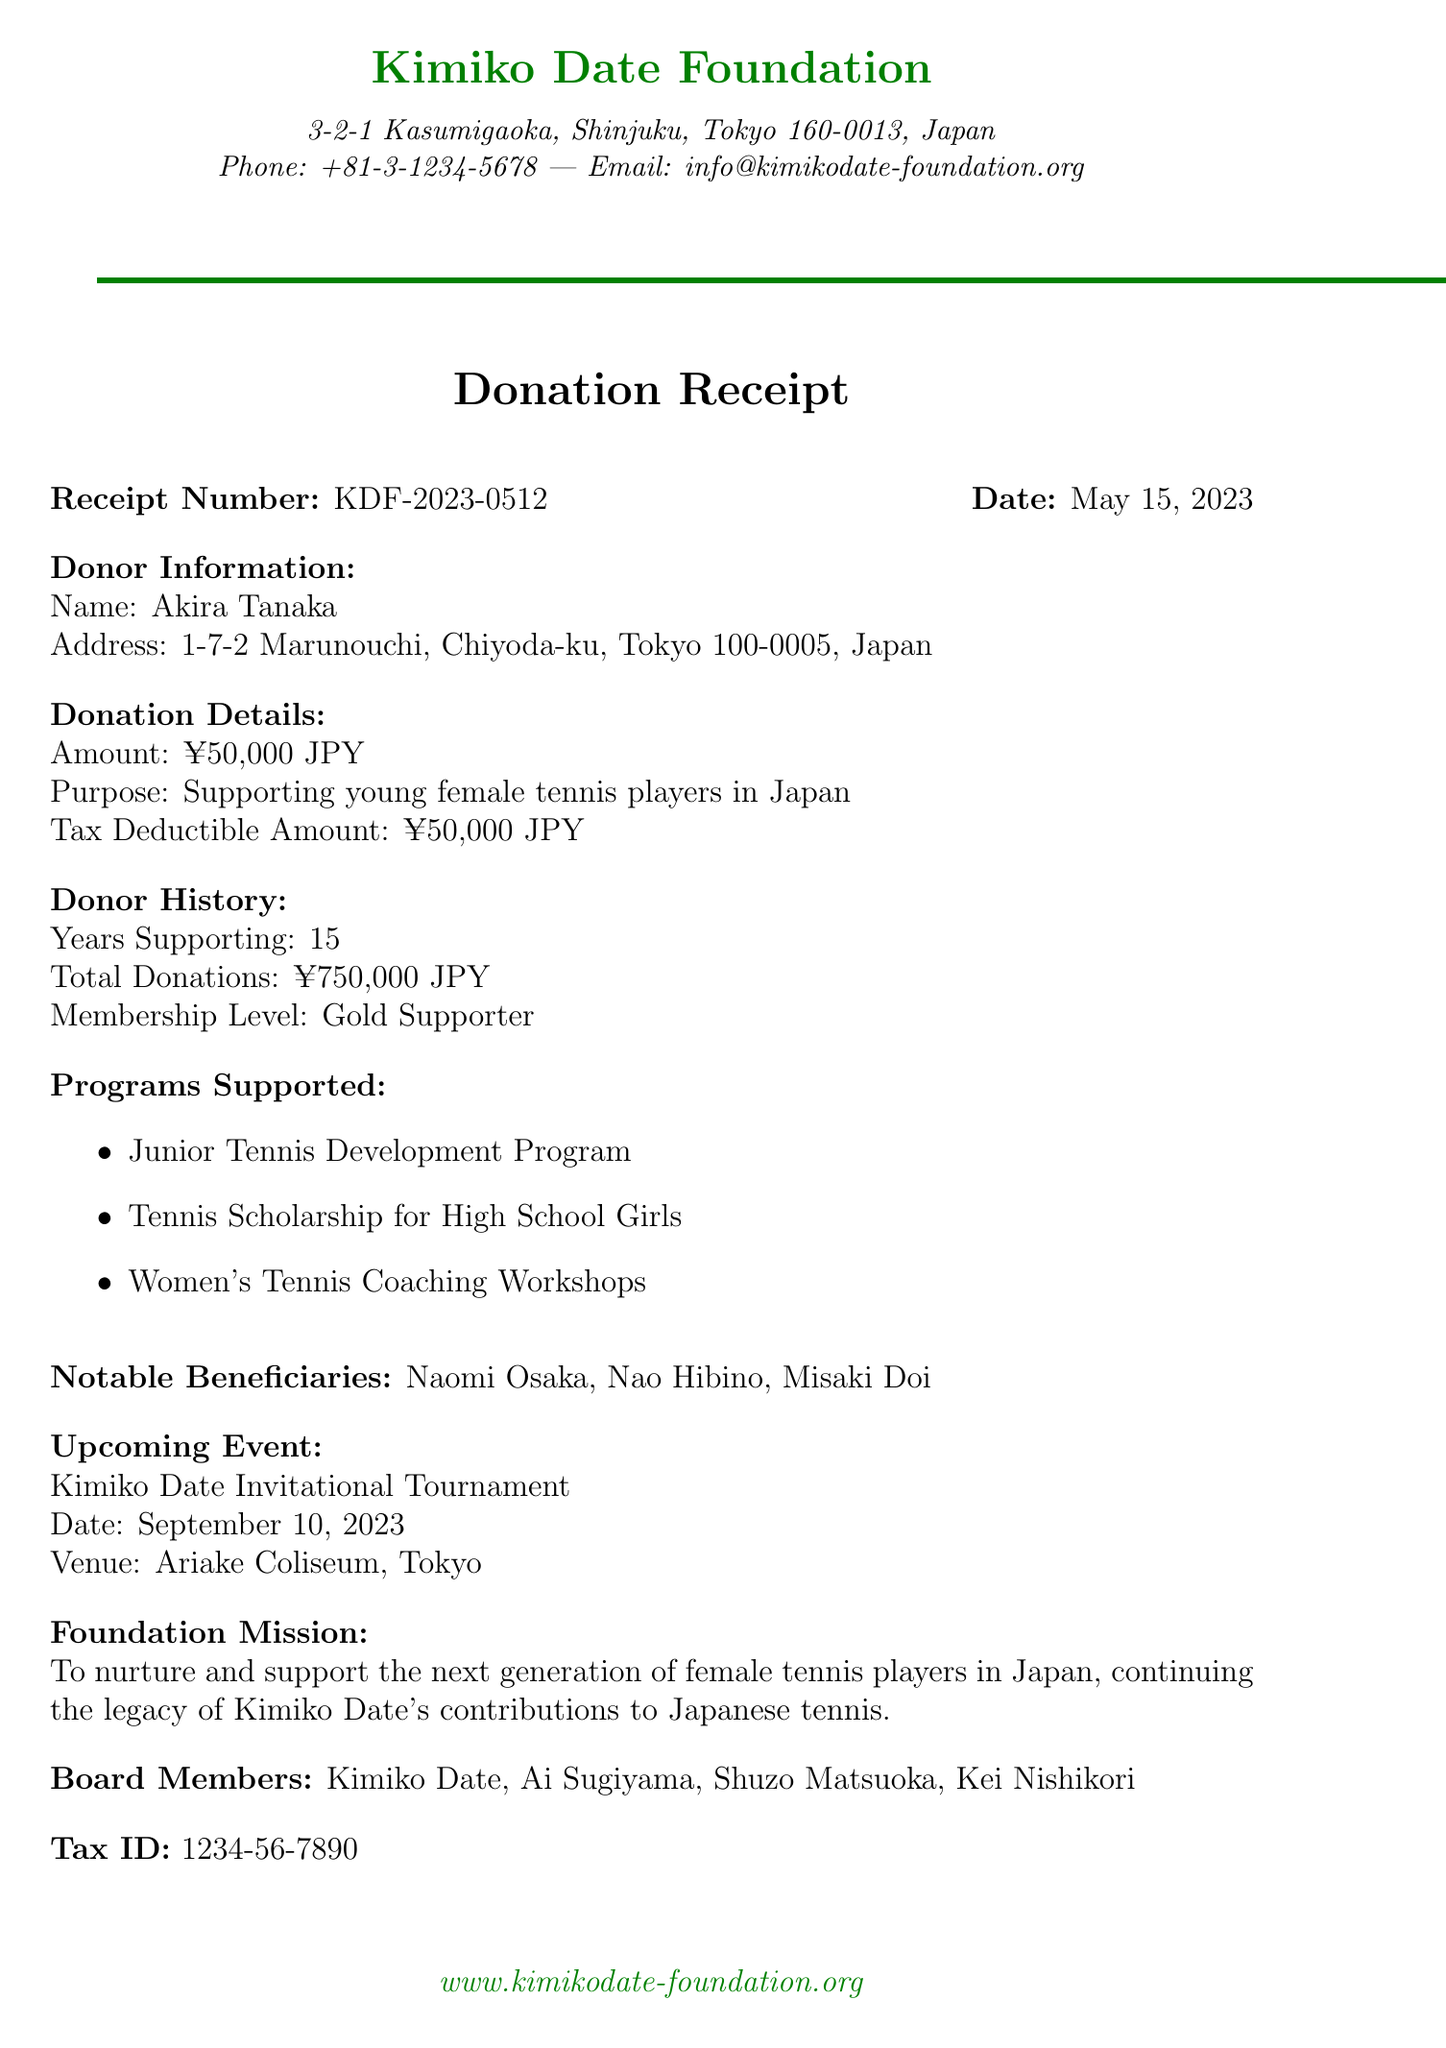What is the name of the foundation? The foundation is called the Kimiko Date Foundation.
Answer: Kimiko Date Foundation Who is the donor? The donor's name is mentioned in the document as Akira Tanaka.
Answer: Akira Tanaka What is the donation amount? The document states that the donation amount is ¥50,000 JPY.
Answer: ¥50,000 JPY What is the receipt number? The receipt number provided in the document is KDF-2023-0512.
Answer: KDF-2023-0512 How many years has the donor been supporting the foundation? The document indicates that Akira Tanaka has been supporting the foundation for 15 years.
Answer: 15 What is the purpose of the donation? The purpose stated in the document is to support young female tennis players in Japan.
Answer: Supporting young female tennis players in Japan What event is mentioned in the document, and when will it take place? The document mentions the Kimiko Date Invitational Tournament, which is scheduled for September 10, 2023.
Answer: Kimiko Date Invitational Tournament Name two notable beneficiaries mentioned in the document. The document lists Naomi Osaka and Nao Hibino as notable beneficiaries.
Answer: Naomi Osaka, Nao Hibino What is the foundation's mission? The mission described in the document focuses on nurturing and supporting the next generation of female tennis players in Japan.
Answer: To nurture and support the next generation of female tennis players in Japan What is the tax ID number? The tax ID is reported in the document as 1234-56-7890.
Answer: 1234-56-7890 